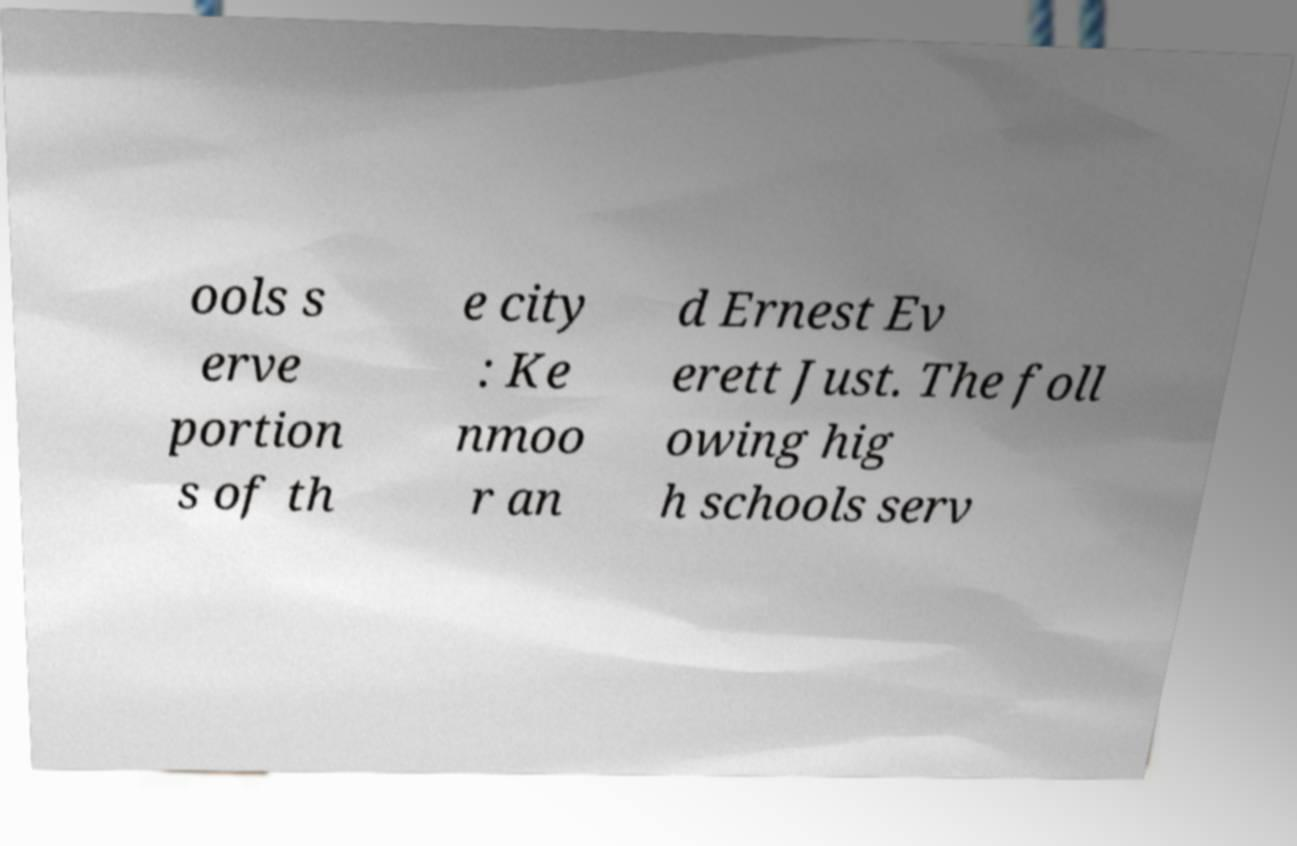Please read and relay the text visible in this image. What does it say? ools s erve portion s of th e city : Ke nmoo r an d Ernest Ev erett Just. The foll owing hig h schools serv 